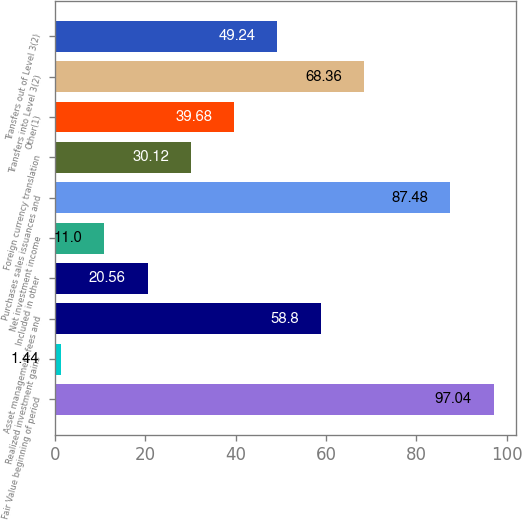Convert chart to OTSL. <chart><loc_0><loc_0><loc_500><loc_500><bar_chart><fcel>Fair Value beginning of period<fcel>Realized investment gains<fcel>Asset management fees and<fcel>Included in other<fcel>Net investment income<fcel>Purchases sales issuances and<fcel>Foreign currency translation<fcel>Other(1)<fcel>Transfers into Level 3(2)<fcel>Transfers out of Level 3(2)<nl><fcel>97.04<fcel>1.44<fcel>58.8<fcel>20.56<fcel>11<fcel>87.48<fcel>30.12<fcel>39.68<fcel>68.36<fcel>49.24<nl></chart> 